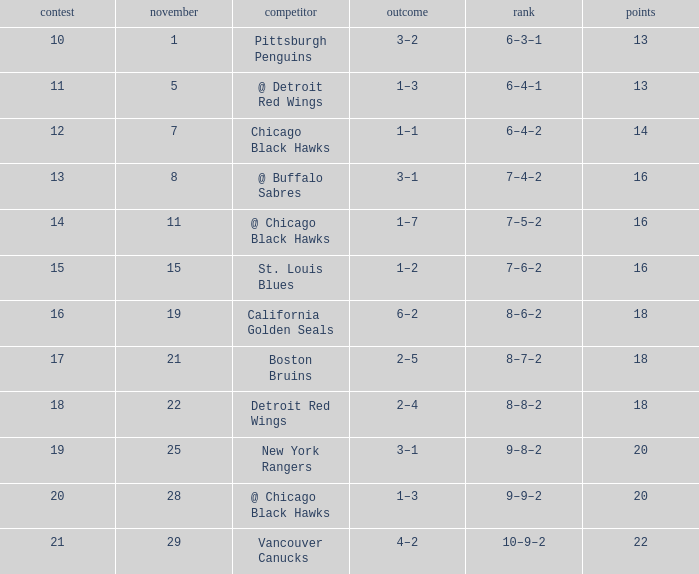What record has a november greater than 11, and st. louis blues as the opponent? 7–6–2. 